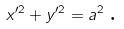<formula> <loc_0><loc_0><loc_500><loc_500>x ^ { \prime 2 } + y ^ { \prime 2 } = a ^ { 2 \text { } } \text {.}</formula> 